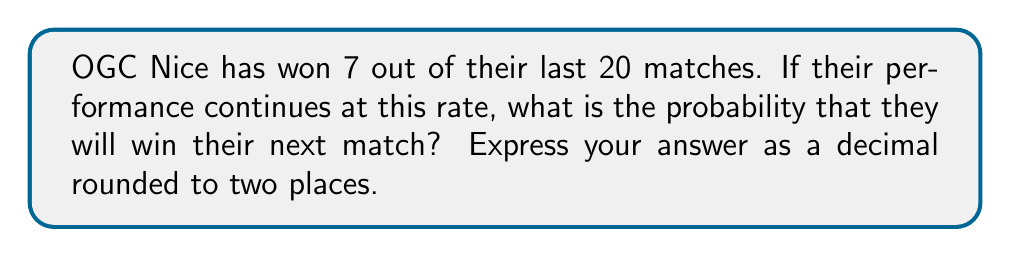Teach me how to tackle this problem. Let's approach this step-by-step:

1) First, we need to calculate the probability of OGC Nice winning a match based on their past performance.

2) The probability is calculated by dividing the number of favorable outcomes by the total number of possible outcomes:

   $$ P(\text{win}) = \frac{\text{Number of wins}}{\text{Total number of matches}} $$

3) We know that OGC Nice has won 7 out of their last 20 matches. Let's plug these numbers into our formula:

   $$ P(\text{win}) = \frac{7}{20} $$

4) Now, let's perform the division:

   $$ P(\text{win}) = 0.35 $$

5) The question asks for the answer rounded to two decimal places, and 0.35 is already in that form.

Therefore, if OGC Nice's performance continues at the same rate, the probability of them winning their next match is 0.35 or 35%.
Answer: 0.35 